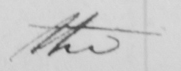Please provide the text content of this handwritten line. the 